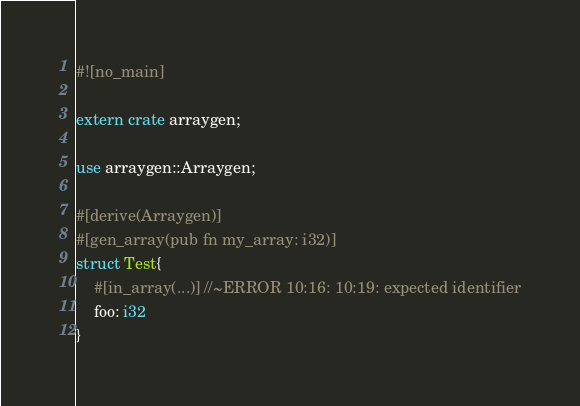Convert code to text. <code><loc_0><loc_0><loc_500><loc_500><_Rust_>#![no_main]

extern crate arraygen;

use arraygen::Arraygen;

#[derive(Arraygen)]
#[gen_array(pub fn my_array: i32)]
struct Test{
    #[in_array(...)] //~ERROR 10:16: 10:19: expected identifier
    foo: i32
}</code> 